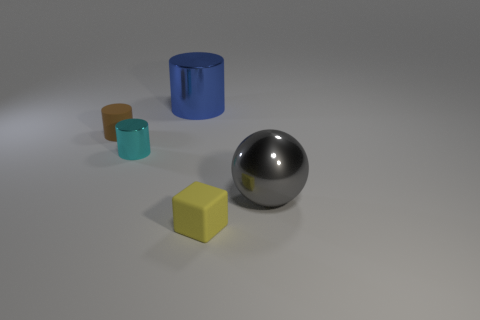Is there a large yellow object of the same shape as the tiny yellow matte object?
Your response must be concise. No. There is a cylinder that is the same size as the gray metallic object; what color is it?
Offer a very short reply. Blue. What size is the cyan shiny object behind the tiny matte cube?
Offer a very short reply. Small. Are there any metal things right of the cylinder that is behind the brown rubber object?
Offer a very short reply. Yes. Do the small object left of the cyan cylinder and the big gray ball have the same material?
Provide a short and direct response. No. How many things are behind the big gray object and right of the small brown object?
Ensure brevity in your answer.  2. How many cyan things have the same material as the blue object?
Provide a short and direct response. 1. There is another small cylinder that is the same material as the blue cylinder; what color is it?
Keep it short and to the point. Cyan. Is the number of cyan metal objects less than the number of tiny red cylinders?
Keep it short and to the point. No. What material is the cylinder in front of the matte thing behind the large object on the right side of the small yellow matte block made of?
Give a very brief answer. Metal. 